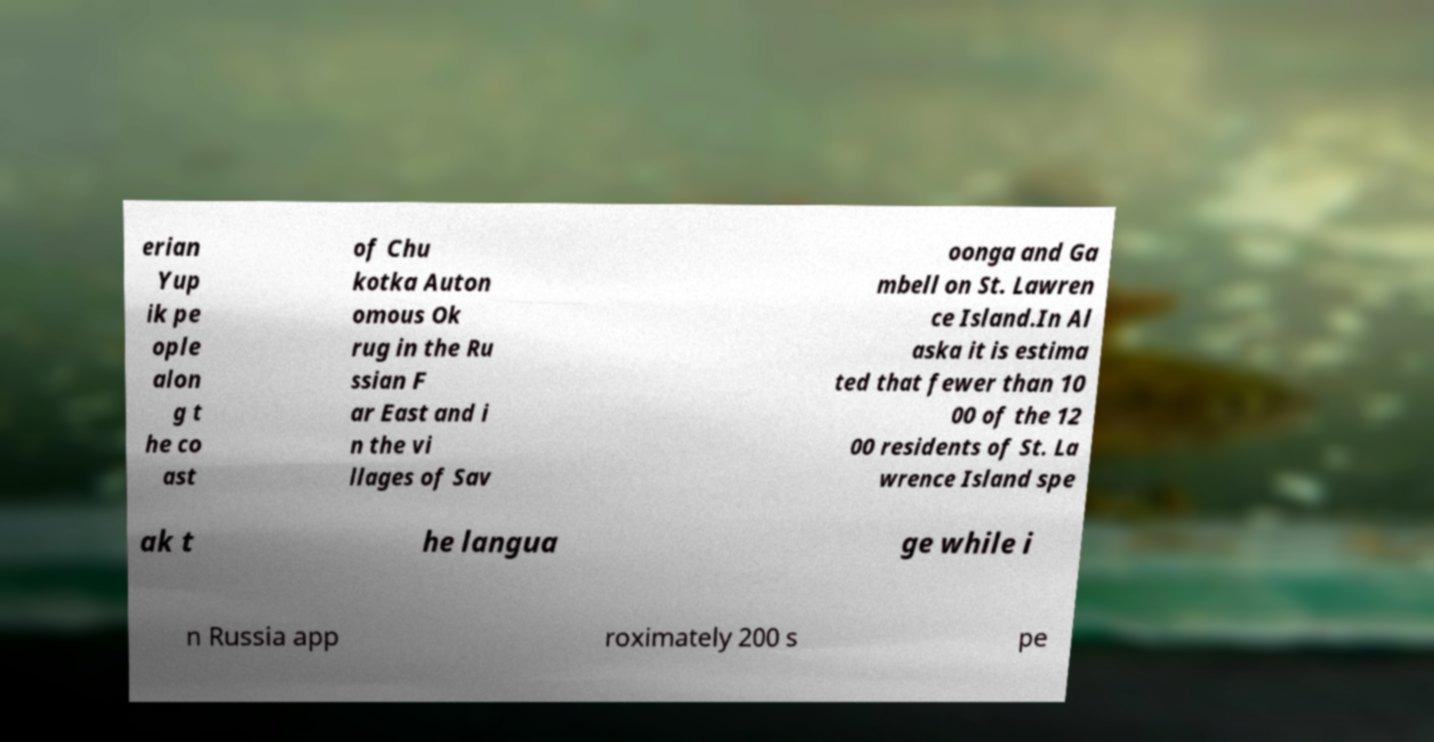Can you read and provide the text displayed in the image?This photo seems to have some interesting text. Can you extract and type it out for me? erian Yup ik pe ople alon g t he co ast of Chu kotka Auton omous Ok rug in the Ru ssian F ar East and i n the vi llages of Sav oonga and Ga mbell on St. Lawren ce Island.In Al aska it is estima ted that fewer than 10 00 of the 12 00 residents of St. La wrence Island spe ak t he langua ge while i n Russia app roximately 200 s pe 